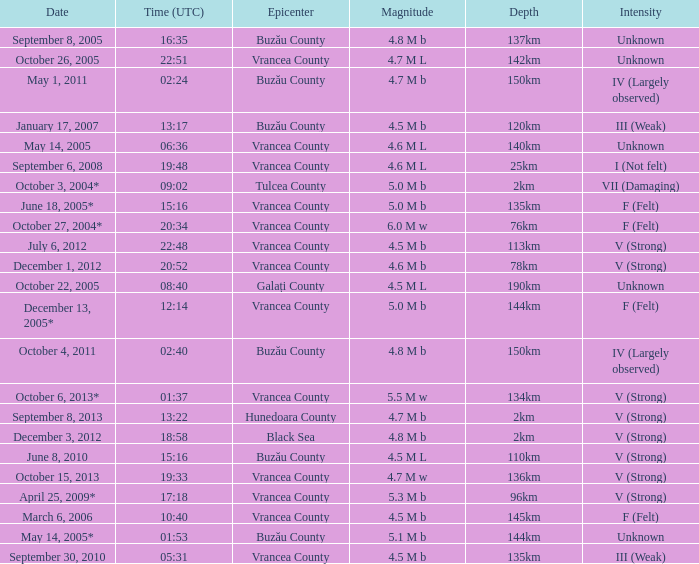What is the magnitude with epicenter at Vrancea County, unknown intensity and which happened at 06:36? 4.6 M L. 